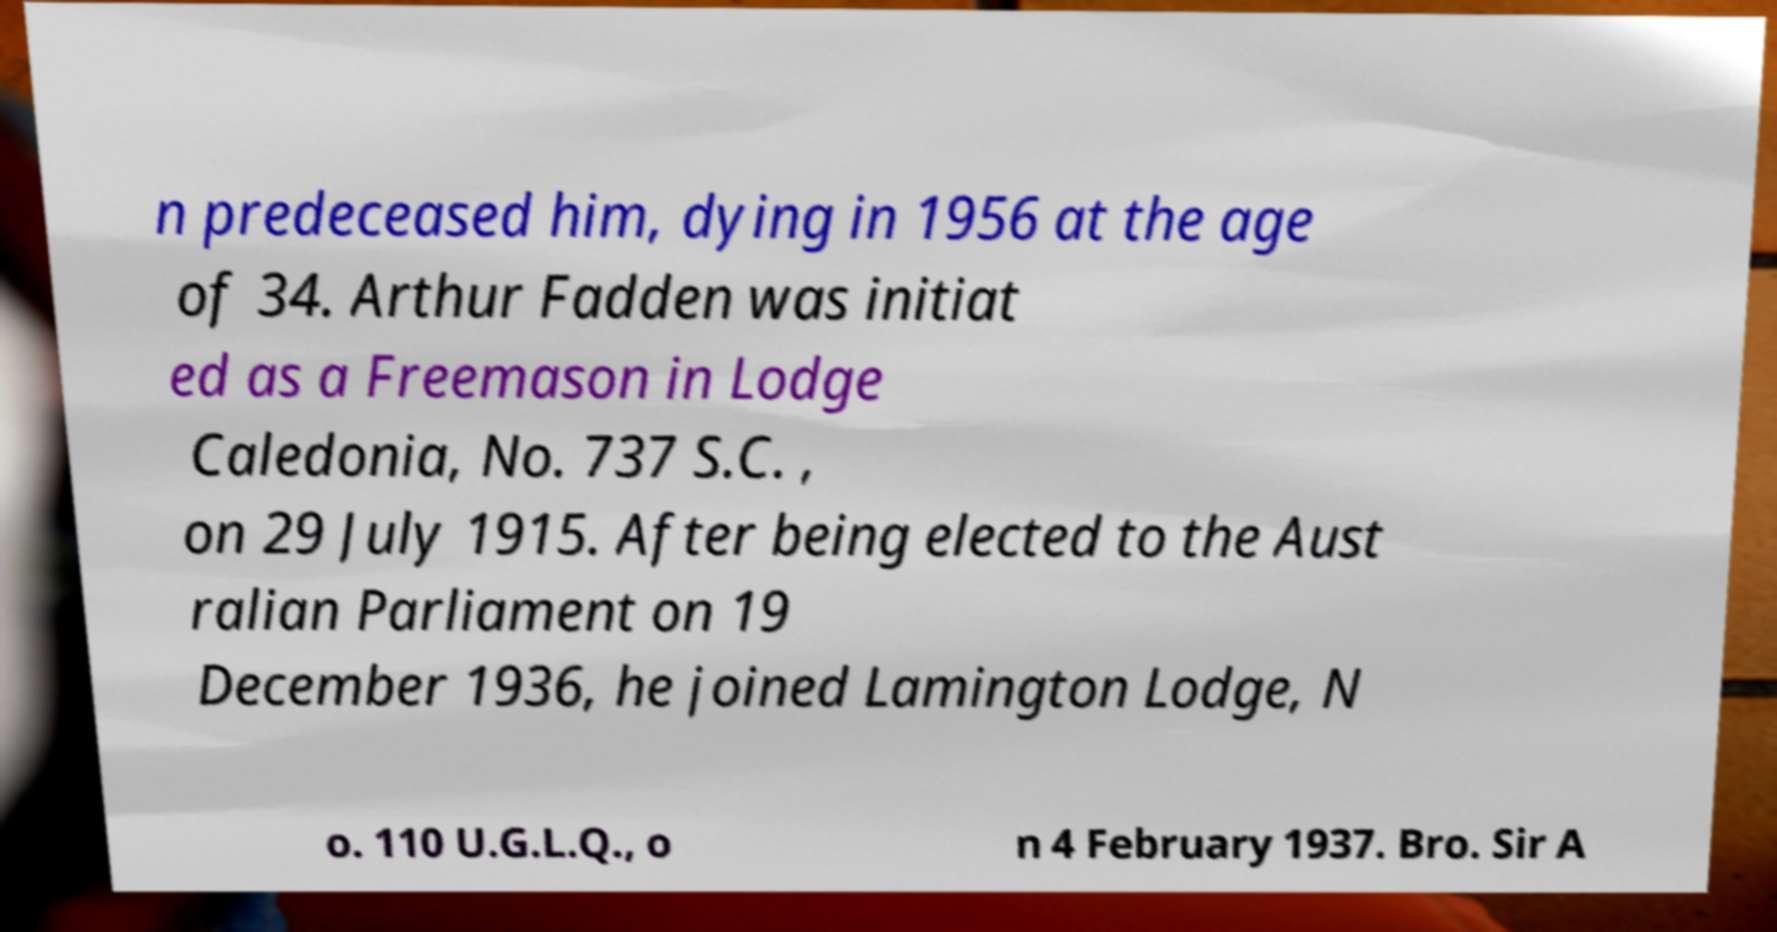Could you assist in decoding the text presented in this image and type it out clearly? n predeceased him, dying in 1956 at the age of 34. Arthur Fadden was initiat ed as a Freemason in Lodge Caledonia, No. 737 S.C. , on 29 July 1915. After being elected to the Aust ralian Parliament on 19 December 1936, he joined Lamington Lodge, N o. 110 U.G.L.Q., o n 4 February 1937. Bro. Sir A 